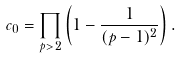<formula> <loc_0><loc_0><loc_500><loc_500>c _ { 0 } = \prod _ { p > 2 } \left ( 1 - \frac { 1 } { ( p - 1 ) ^ { 2 } } \right ) .</formula> 